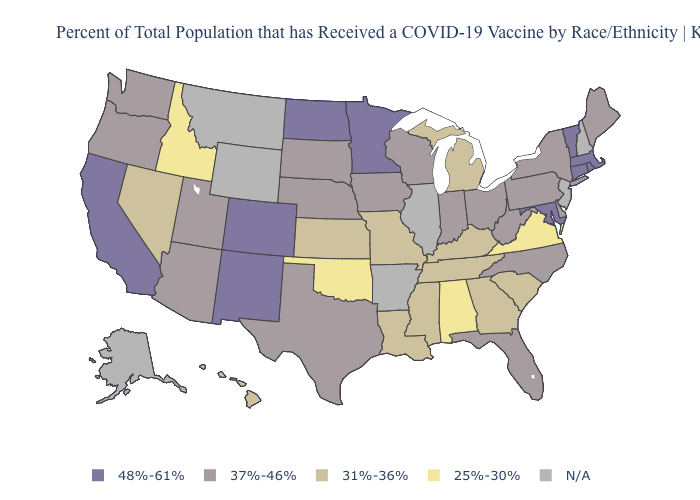What is the value of Minnesota?
Concise answer only. 48%-61%. Is the legend a continuous bar?
Concise answer only. No. Does Arizona have the highest value in the West?
Be succinct. No. What is the value of Washington?
Keep it brief. 37%-46%. Among the states that border Alabama , which have the highest value?
Answer briefly. Florida. What is the highest value in states that border South Dakota?
Be succinct. 48%-61%. What is the highest value in the MidWest ?
Short answer required. 48%-61%. Which states hav the highest value in the South?
Answer briefly. Maryland. Does Virginia have the lowest value in the South?
Write a very short answer. Yes. Name the states that have a value in the range N/A?
Quick response, please. Alaska, Arkansas, Illinois, Montana, New Hampshire, New Jersey, Wyoming. What is the highest value in states that border Colorado?
Be succinct. 48%-61%. What is the highest value in the USA?
Short answer required. 48%-61%. Which states hav the highest value in the West?
Short answer required. California, Colorado, New Mexico. Which states have the highest value in the USA?
Write a very short answer. California, Colorado, Connecticut, Maryland, Massachusetts, Minnesota, New Mexico, North Dakota, Rhode Island, Vermont. What is the highest value in the USA?
Answer briefly. 48%-61%. 